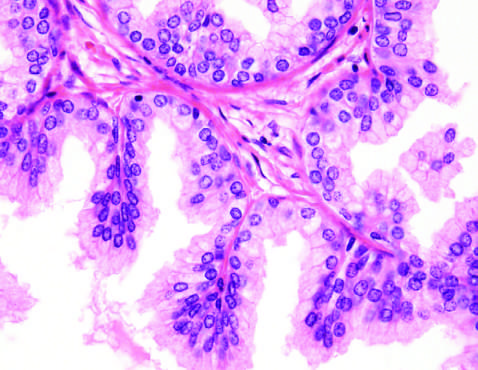s typical tuberculous granuloma showing an area of central necrosis caused predominantly by stromal, rather than glandular, proliferation in other cases of nodular hyperplasia?
Answer the question using a single word or phrase. No 